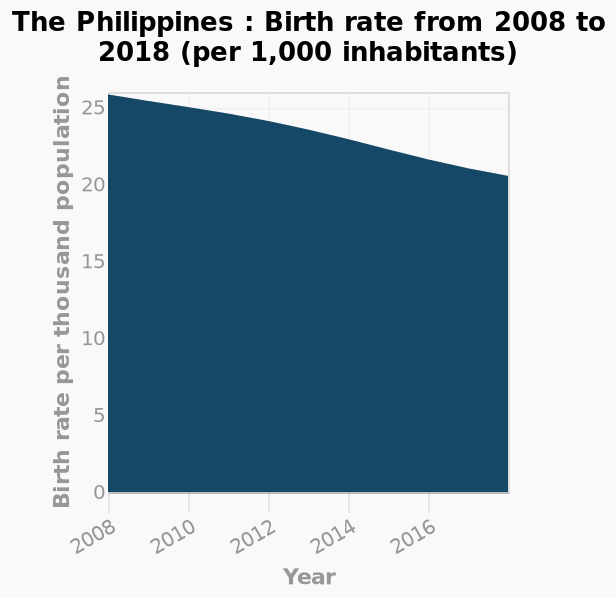<image>
Offer a thorough analysis of the image. In 10 years the birth rate in the Philippines has decreased from 26 per thousand people to 20 per thousand people. please describe the details of the chart The Philippines : Birth rate from 2008 to 2018 (per 1,000 inhabitants) is a area graph. The y-axis measures Birth rate per thousand population using linear scale with a minimum of 0 and a maximum of 25 while the x-axis shows Year as linear scale of range 2008 to 2016. What was the trend in the birth rate in the Philippines between 2008 and 2020? The birth rate in the Philippines exhibited a gradual decline between 2008 and 2020. What does the x-axis represent in the line diagram?  The x-axis represents the years from 2008 to 2016. Does the x-axis represent the years from 2018 to 2016? No. The x-axis represents the years from 2008 to 2016. 